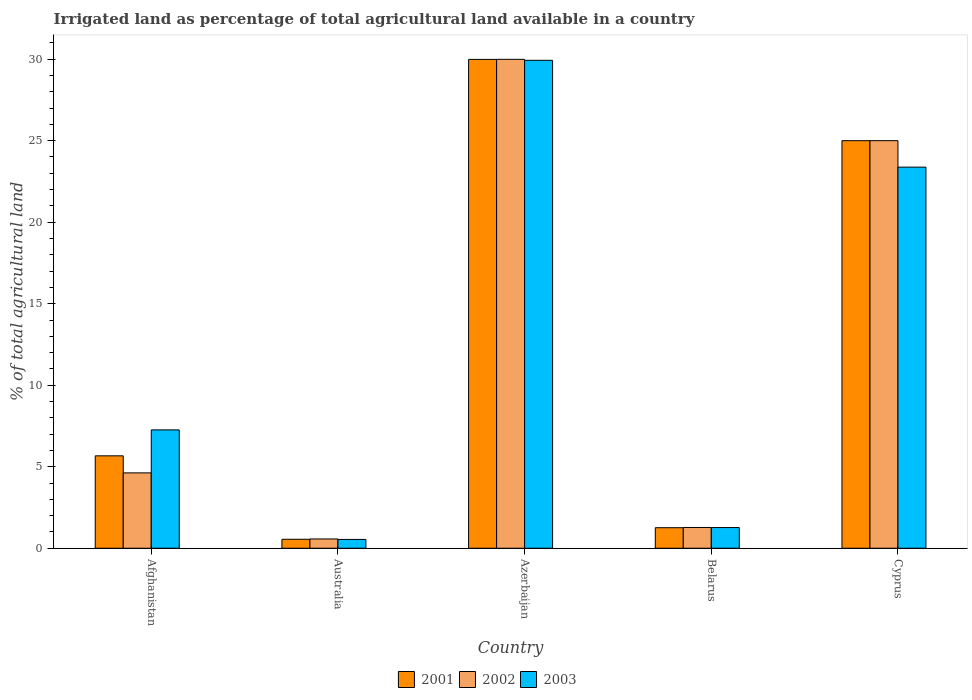How many different coloured bars are there?
Your answer should be very brief. 3. Are the number of bars per tick equal to the number of legend labels?
Make the answer very short. Yes. Are the number of bars on each tick of the X-axis equal?
Your answer should be very brief. Yes. How many bars are there on the 3rd tick from the left?
Make the answer very short. 3. In how many cases, is the number of bars for a given country not equal to the number of legend labels?
Your response must be concise. 0. What is the percentage of irrigated land in 2002 in Cyprus?
Offer a very short reply. 25. Across all countries, what is the maximum percentage of irrigated land in 2003?
Your answer should be very brief. 29.93. Across all countries, what is the minimum percentage of irrigated land in 2003?
Your answer should be very brief. 0.54. In which country was the percentage of irrigated land in 2002 maximum?
Offer a very short reply. Azerbaijan. In which country was the percentage of irrigated land in 2001 minimum?
Offer a very short reply. Australia. What is the total percentage of irrigated land in 2003 in the graph?
Your response must be concise. 62.37. What is the difference between the percentage of irrigated land in 2003 in Australia and that in Belarus?
Keep it short and to the point. -0.73. What is the difference between the percentage of irrigated land in 2003 in Afghanistan and the percentage of irrigated land in 2001 in Belarus?
Keep it short and to the point. 6. What is the average percentage of irrigated land in 2001 per country?
Offer a very short reply. 12.49. What is the difference between the percentage of irrigated land of/in 2002 and percentage of irrigated land of/in 2001 in Azerbaijan?
Keep it short and to the point. 0. In how many countries, is the percentage of irrigated land in 2002 greater than 9 %?
Ensure brevity in your answer.  2. What is the ratio of the percentage of irrigated land in 2002 in Azerbaijan to that in Cyprus?
Your answer should be compact. 1.2. What is the difference between the highest and the second highest percentage of irrigated land in 2001?
Your answer should be compact. 19.33. What is the difference between the highest and the lowest percentage of irrigated land in 2003?
Your answer should be compact. 29.39. Is the sum of the percentage of irrigated land in 2003 in Afghanistan and Australia greater than the maximum percentage of irrigated land in 2001 across all countries?
Your answer should be compact. No. What does the 3rd bar from the left in Australia represents?
Offer a terse response. 2003. What does the 1st bar from the right in Afghanistan represents?
Your response must be concise. 2003. Are the values on the major ticks of Y-axis written in scientific E-notation?
Your answer should be compact. No. How many legend labels are there?
Keep it short and to the point. 3. How are the legend labels stacked?
Offer a terse response. Horizontal. What is the title of the graph?
Ensure brevity in your answer.  Irrigated land as percentage of total agricultural land available in a country. What is the label or title of the Y-axis?
Provide a succinct answer. % of total agricultural land. What is the % of total agricultural land in 2001 in Afghanistan?
Ensure brevity in your answer.  5.67. What is the % of total agricultural land in 2002 in Afghanistan?
Give a very brief answer. 4.62. What is the % of total agricultural land of 2003 in Afghanistan?
Make the answer very short. 7.26. What is the % of total agricultural land of 2001 in Australia?
Your answer should be compact. 0.55. What is the % of total agricultural land of 2002 in Australia?
Provide a succinct answer. 0.57. What is the % of total agricultural land of 2003 in Australia?
Make the answer very short. 0.54. What is the % of total agricultural land of 2001 in Azerbaijan?
Your answer should be compact. 29.99. What is the % of total agricultural land in 2002 in Azerbaijan?
Make the answer very short. 29.99. What is the % of total agricultural land in 2003 in Azerbaijan?
Offer a terse response. 29.93. What is the % of total agricultural land in 2001 in Belarus?
Provide a short and direct response. 1.26. What is the % of total agricultural land in 2002 in Belarus?
Give a very brief answer. 1.27. What is the % of total agricultural land in 2003 in Belarus?
Your answer should be very brief. 1.27. What is the % of total agricultural land in 2003 in Cyprus?
Offer a very short reply. 23.38. Across all countries, what is the maximum % of total agricultural land in 2001?
Offer a terse response. 29.99. Across all countries, what is the maximum % of total agricultural land of 2002?
Keep it short and to the point. 29.99. Across all countries, what is the maximum % of total agricultural land of 2003?
Provide a short and direct response. 29.93. Across all countries, what is the minimum % of total agricultural land of 2001?
Your answer should be compact. 0.55. Across all countries, what is the minimum % of total agricultural land in 2002?
Make the answer very short. 0.57. Across all countries, what is the minimum % of total agricultural land of 2003?
Ensure brevity in your answer.  0.54. What is the total % of total agricultural land of 2001 in the graph?
Your answer should be very brief. 62.46. What is the total % of total agricultural land in 2002 in the graph?
Ensure brevity in your answer.  61.46. What is the total % of total agricultural land in 2003 in the graph?
Offer a very short reply. 62.37. What is the difference between the % of total agricultural land of 2001 in Afghanistan and that in Australia?
Offer a very short reply. 5.12. What is the difference between the % of total agricultural land of 2002 in Afghanistan and that in Australia?
Give a very brief answer. 4.05. What is the difference between the % of total agricultural land in 2003 in Afghanistan and that in Australia?
Keep it short and to the point. 6.72. What is the difference between the % of total agricultural land in 2001 in Afghanistan and that in Azerbaijan?
Your response must be concise. -24.32. What is the difference between the % of total agricultural land in 2002 in Afghanistan and that in Azerbaijan?
Your answer should be compact. -25.37. What is the difference between the % of total agricultural land in 2003 in Afghanistan and that in Azerbaijan?
Your answer should be compact. -22.67. What is the difference between the % of total agricultural land in 2001 in Afghanistan and that in Belarus?
Your response must be concise. 4.41. What is the difference between the % of total agricultural land in 2002 in Afghanistan and that in Belarus?
Your answer should be very brief. 3.35. What is the difference between the % of total agricultural land of 2003 in Afghanistan and that in Belarus?
Offer a terse response. 5.99. What is the difference between the % of total agricultural land of 2001 in Afghanistan and that in Cyprus?
Give a very brief answer. -19.33. What is the difference between the % of total agricultural land of 2002 in Afghanistan and that in Cyprus?
Make the answer very short. -20.38. What is the difference between the % of total agricultural land of 2003 in Afghanistan and that in Cyprus?
Your answer should be very brief. -16.12. What is the difference between the % of total agricultural land in 2001 in Australia and that in Azerbaijan?
Make the answer very short. -29.44. What is the difference between the % of total agricultural land in 2002 in Australia and that in Azerbaijan?
Your answer should be very brief. -29.42. What is the difference between the % of total agricultural land of 2003 in Australia and that in Azerbaijan?
Your answer should be compact. -29.39. What is the difference between the % of total agricultural land of 2001 in Australia and that in Belarus?
Your answer should be compact. -0.71. What is the difference between the % of total agricultural land in 2002 in Australia and that in Belarus?
Offer a terse response. -0.7. What is the difference between the % of total agricultural land of 2003 in Australia and that in Belarus?
Make the answer very short. -0.73. What is the difference between the % of total agricultural land of 2001 in Australia and that in Cyprus?
Your answer should be compact. -24.45. What is the difference between the % of total agricultural land of 2002 in Australia and that in Cyprus?
Your answer should be compact. -24.43. What is the difference between the % of total agricultural land in 2003 in Australia and that in Cyprus?
Offer a terse response. -22.84. What is the difference between the % of total agricultural land in 2001 in Azerbaijan and that in Belarus?
Give a very brief answer. 28.73. What is the difference between the % of total agricultural land in 2002 in Azerbaijan and that in Belarus?
Provide a short and direct response. 28.72. What is the difference between the % of total agricultural land in 2003 in Azerbaijan and that in Belarus?
Provide a succinct answer. 28.66. What is the difference between the % of total agricultural land of 2001 in Azerbaijan and that in Cyprus?
Your answer should be very brief. 4.99. What is the difference between the % of total agricultural land of 2002 in Azerbaijan and that in Cyprus?
Your answer should be very brief. 4.99. What is the difference between the % of total agricultural land of 2003 in Azerbaijan and that in Cyprus?
Ensure brevity in your answer.  6.55. What is the difference between the % of total agricultural land of 2001 in Belarus and that in Cyprus?
Your response must be concise. -23.74. What is the difference between the % of total agricultural land of 2002 in Belarus and that in Cyprus?
Give a very brief answer. -23.73. What is the difference between the % of total agricultural land in 2003 in Belarus and that in Cyprus?
Your answer should be compact. -22.11. What is the difference between the % of total agricultural land of 2001 in Afghanistan and the % of total agricultural land of 2002 in Australia?
Ensure brevity in your answer.  5.1. What is the difference between the % of total agricultural land of 2001 in Afghanistan and the % of total agricultural land of 2003 in Australia?
Offer a very short reply. 5.13. What is the difference between the % of total agricultural land in 2002 in Afghanistan and the % of total agricultural land in 2003 in Australia?
Offer a terse response. 4.08. What is the difference between the % of total agricultural land of 2001 in Afghanistan and the % of total agricultural land of 2002 in Azerbaijan?
Keep it short and to the point. -24.32. What is the difference between the % of total agricultural land of 2001 in Afghanistan and the % of total agricultural land of 2003 in Azerbaijan?
Your response must be concise. -24.26. What is the difference between the % of total agricultural land of 2002 in Afghanistan and the % of total agricultural land of 2003 in Azerbaijan?
Offer a terse response. -25.31. What is the difference between the % of total agricultural land of 2001 in Afghanistan and the % of total agricultural land of 2002 in Belarus?
Offer a terse response. 4.39. What is the difference between the % of total agricultural land in 2001 in Afghanistan and the % of total agricultural land in 2003 in Belarus?
Your response must be concise. 4.4. What is the difference between the % of total agricultural land of 2002 in Afghanistan and the % of total agricultural land of 2003 in Belarus?
Your answer should be compact. 3.35. What is the difference between the % of total agricultural land in 2001 in Afghanistan and the % of total agricultural land in 2002 in Cyprus?
Provide a succinct answer. -19.33. What is the difference between the % of total agricultural land of 2001 in Afghanistan and the % of total agricultural land of 2003 in Cyprus?
Offer a terse response. -17.71. What is the difference between the % of total agricultural land of 2002 in Afghanistan and the % of total agricultural land of 2003 in Cyprus?
Your response must be concise. -18.75. What is the difference between the % of total agricultural land in 2001 in Australia and the % of total agricultural land in 2002 in Azerbaijan?
Offer a terse response. -29.44. What is the difference between the % of total agricultural land of 2001 in Australia and the % of total agricultural land of 2003 in Azerbaijan?
Your response must be concise. -29.38. What is the difference between the % of total agricultural land in 2002 in Australia and the % of total agricultural land in 2003 in Azerbaijan?
Make the answer very short. -29.36. What is the difference between the % of total agricultural land in 2001 in Australia and the % of total agricultural land in 2002 in Belarus?
Your answer should be compact. -0.72. What is the difference between the % of total agricultural land in 2001 in Australia and the % of total agricultural land in 2003 in Belarus?
Your response must be concise. -0.72. What is the difference between the % of total agricultural land of 2002 in Australia and the % of total agricultural land of 2003 in Belarus?
Provide a short and direct response. -0.7. What is the difference between the % of total agricultural land in 2001 in Australia and the % of total agricultural land in 2002 in Cyprus?
Keep it short and to the point. -24.45. What is the difference between the % of total agricultural land in 2001 in Australia and the % of total agricultural land in 2003 in Cyprus?
Keep it short and to the point. -22.83. What is the difference between the % of total agricultural land of 2002 in Australia and the % of total agricultural land of 2003 in Cyprus?
Your answer should be very brief. -22.81. What is the difference between the % of total agricultural land of 2001 in Azerbaijan and the % of total agricultural land of 2002 in Belarus?
Your response must be concise. 28.71. What is the difference between the % of total agricultural land of 2001 in Azerbaijan and the % of total agricultural land of 2003 in Belarus?
Your answer should be compact. 28.72. What is the difference between the % of total agricultural land in 2002 in Azerbaijan and the % of total agricultural land in 2003 in Belarus?
Keep it short and to the point. 28.72. What is the difference between the % of total agricultural land of 2001 in Azerbaijan and the % of total agricultural land of 2002 in Cyprus?
Your response must be concise. 4.99. What is the difference between the % of total agricultural land of 2001 in Azerbaijan and the % of total agricultural land of 2003 in Cyprus?
Your answer should be very brief. 6.61. What is the difference between the % of total agricultural land in 2002 in Azerbaijan and the % of total agricultural land in 2003 in Cyprus?
Keep it short and to the point. 6.61. What is the difference between the % of total agricultural land of 2001 in Belarus and the % of total agricultural land of 2002 in Cyprus?
Your response must be concise. -23.74. What is the difference between the % of total agricultural land of 2001 in Belarus and the % of total agricultural land of 2003 in Cyprus?
Offer a very short reply. -22.12. What is the difference between the % of total agricultural land in 2002 in Belarus and the % of total agricultural land in 2003 in Cyprus?
Keep it short and to the point. -22.1. What is the average % of total agricultural land in 2001 per country?
Make the answer very short. 12.49. What is the average % of total agricultural land in 2002 per country?
Offer a terse response. 12.29. What is the average % of total agricultural land of 2003 per country?
Offer a very short reply. 12.47. What is the difference between the % of total agricultural land of 2001 and % of total agricultural land of 2002 in Afghanistan?
Give a very brief answer. 1.05. What is the difference between the % of total agricultural land of 2001 and % of total agricultural land of 2003 in Afghanistan?
Give a very brief answer. -1.59. What is the difference between the % of total agricultural land in 2002 and % of total agricultural land in 2003 in Afghanistan?
Keep it short and to the point. -2.64. What is the difference between the % of total agricultural land in 2001 and % of total agricultural land in 2002 in Australia?
Provide a short and direct response. -0.02. What is the difference between the % of total agricultural land in 2001 and % of total agricultural land in 2003 in Australia?
Your answer should be compact. 0.01. What is the difference between the % of total agricultural land in 2002 and % of total agricultural land in 2003 in Australia?
Offer a very short reply. 0.03. What is the difference between the % of total agricultural land in 2001 and % of total agricultural land in 2002 in Azerbaijan?
Make the answer very short. -0. What is the difference between the % of total agricultural land in 2001 and % of total agricultural land in 2003 in Azerbaijan?
Your answer should be compact. 0.06. What is the difference between the % of total agricultural land in 2002 and % of total agricultural land in 2003 in Azerbaijan?
Offer a terse response. 0.06. What is the difference between the % of total agricultural land in 2001 and % of total agricultural land in 2002 in Belarus?
Give a very brief answer. -0.01. What is the difference between the % of total agricultural land of 2001 and % of total agricultural land of 2003 in Belarus?
Offer a terse response. -0.01. What is the difference between the % of total agricultural land in 2002 and % of total agricultural land in 2003 in Belarus?
Keep it short and to the point. 0.01. What is the difference between the % of total agricultural land in 2001 and % of total agricultural land in 2002 in Cyprus?
Make the answer very short. 0. What is the difference between the % of total agricultural land in 2001 and % of total agricultural land in 2003 in Cyprus?
Ensure brevity in your answer.  1.62. What is the difference between the % of total agricultural land in 2002 and % of total agricultural land in 2003 in Cyprus?
Your answer should be compact. 1.62. What is the ratio of the % of total agricultural land in 2001 in Afghanistan to that in Australia?
Make the answer very short. 10.31. What is the ratio of the % of total agricultural land of 2002 in Afghanistan to that in Australia?
Your answer should be compact. 8.12. What is the ratio of the % of total agricultural land of 2003 in Afghanistan to that in Australia?
Ensure brevity in your answer.  13.42. What is the ratio of the % of total agricultural land of 2001 in Afghanistan to that in Azerbaijan?
Give a very brief answer. 0.19. What is the ratio of the % of total agricultural land of 2002 in Afghanistan to that in Azerbaijan?
Offer a terse response. 0.15. What is the ratio of the % of total agricultural land of 2003 in Afghanistan to that in Azerbaijan?
Provide a succinct answer. 0.24. What is the ratio of the % of total agricultural land in 2001 in Afghanistan to that in Belarus?
Provide a succinct answer. 4.5. What is the ratio of the % of total agricultural land of 2002 in Afghanistan to that in Belarus?
Ensure brevity in your answer.  3.63. What is the ratio of the % of total agricultural land in 2003 in Afghanistan to that in Belarus?
Provide a short and direct response. 5.72. What is the ratio of the % of total agricultural land of 2001 in Afghanistan to that in Cyprus?
Provide a short and direct response. 0.23. What is the ratio of the % of total agricultural land of 2002 in Afghanistan to that in Cyprus?
Provide a short and direct response. 0.18. What is the ratio of the % of total agricultural land of 2003 in Afghanistan to that in Cyprus?
Provide a short and direct response. 0.31. What is the ratio of the % of total agricultural land of 2001 in Australia to that in Azerbaijan?
Your response must be concise. 0.02. What is the ratio of the % of total agricultural land in 2002 in Australia to that in Azerbaijan?
Give a very brief answer. 0.02. What is the ratio of the % of total agricultural land of 2003 in Australia to that in Azerbaijan?
Your response must be concise. 0.02. What is the ratio of the % of total agricultural land in 2001 in Australia to that in Belarus?
Your answer should be very brief. 0.44. What is the ratio of the % of total agricultural land in 2002 in Australia to that in Belarus?
Provide a short and direct response. 0.45. What is the ratio of the % of total agricultural land in 2003 in Australia to that in Belarus?
Your answer should be very brief. 0.43. What is the ratio of the % of total agricultural land of 2001 in Australia to that in Cyprus?
Keep it short and to the point. 0.02. What is the ratio of the % of total agricultural land of 2002 in Australia to that in Cyprus?
Offer a terse response. 0.02. What is the ratio of the % of total agricultural land in 2003 in Australia to that in Cyprus?
Your answer should be compact. 0.02. What is the ratio of the % of total agricultural land in 2001 in Azerbaijan to that in Belarus?
Ensure brevity in your answer.  23.8. What is the ratio of the % of total agricultural land of 2002 in Azerbaijan to that in Belarus?
Give a very brief answer. 23.54. What is the ratio of the % of total agricultural land in 2003 in Azerbaijan to that in Belarus?
Your answer should be very brief. 23.59. What is the ratio of the % of total agricultural land of 2001 in Azerbaijan to that in Cyprus?
Your response must be concise. 1.2. What is the ratio of the % of total agricultural land of 2002 in Azerbaijan to that in Cyprus?
Provide a succinct answer. 1.2. What is the ratio of the % of total agricultural land in 2003 in Azerbaijan to that in Cyprus?
Provide a succinct answer. 1.28. What is the ratio of the % of total agricultural land in 2001 in Belarus to that in Cyprus?
Provide a short and direct response. 0.05. What is the ratio of the % of total agricultural land in 2002 in Belarus to that in Cyprus?
Give a very brief answer. 0.05. What is the ratio of the % of total agricultural land in 2003 in Belarus to that in Cyprus?
Make the answer very short. 0.05. What is the difference between the highest and the second highest % of total agricultural land of 2001?
Your answer should be very brief. 4.99. What is the difference between the highest and the second highest % of total agricultural land of 2002?
Give a very brief answer. 4.99. What is the difference between the highest and the second highest % of total agricultural land in 2003?
Provide a succinct answer. 6.55. What is the difference between the highest and the lowest % of total agricultural land of 2001?
Provide a succinct answer. 29.44. What is the difference between the highest and the lowest % of total agricultural land in 2002?
Your answer should be very brief. 29.42. What is the difference between the highest and the lowest % of total agricultural land of 2003?
Your answer should be very brief. 29.39. 